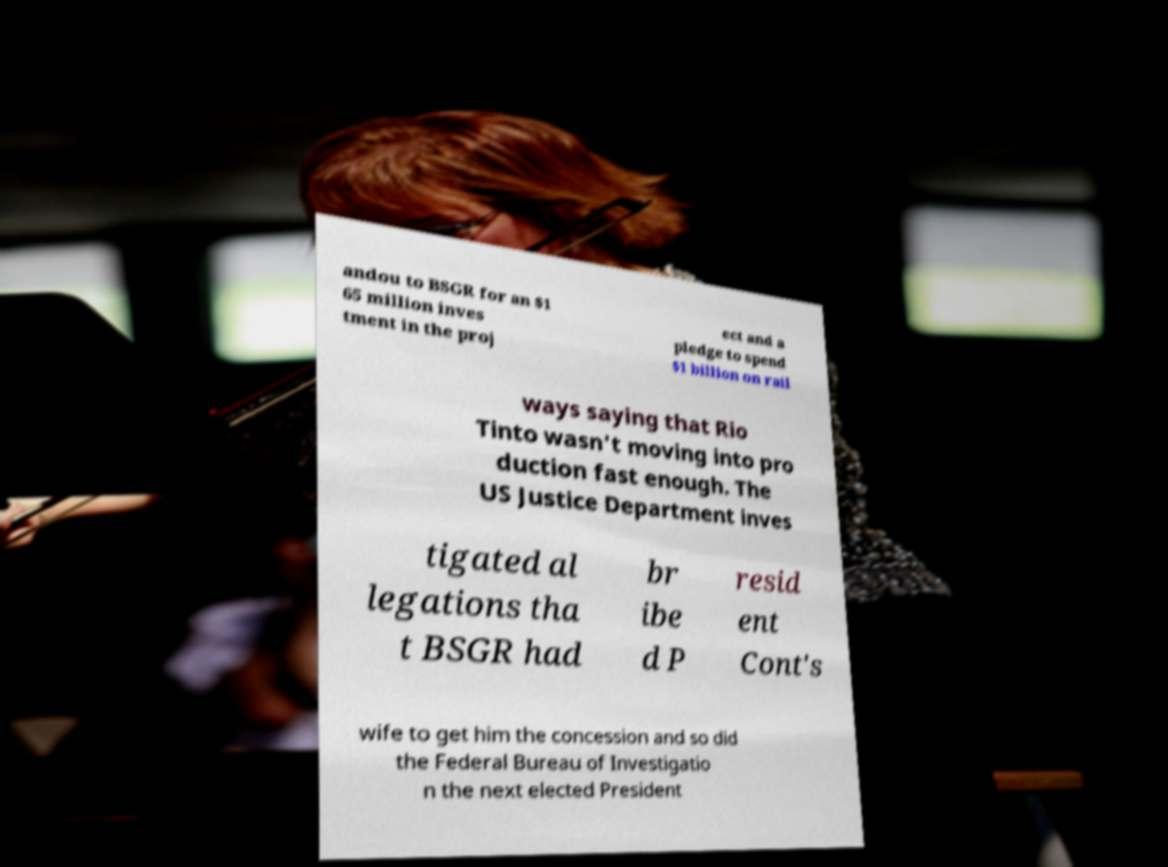What messages or text are displayed in this image? I need them in a readable, typed format. andou to BSGR for an $1 65 million inves tment in the proj ect and a pledge to spend $1 billion on rail ways saying that Rio Tinto wasn't moving into pro duction fast enough. The US Justice Department inves tigated al legations tha t BSGR had br ibe d P resid ent Cont's wife to get him the concession and so did the Federal Bureau of Investigatio n the next elected President 